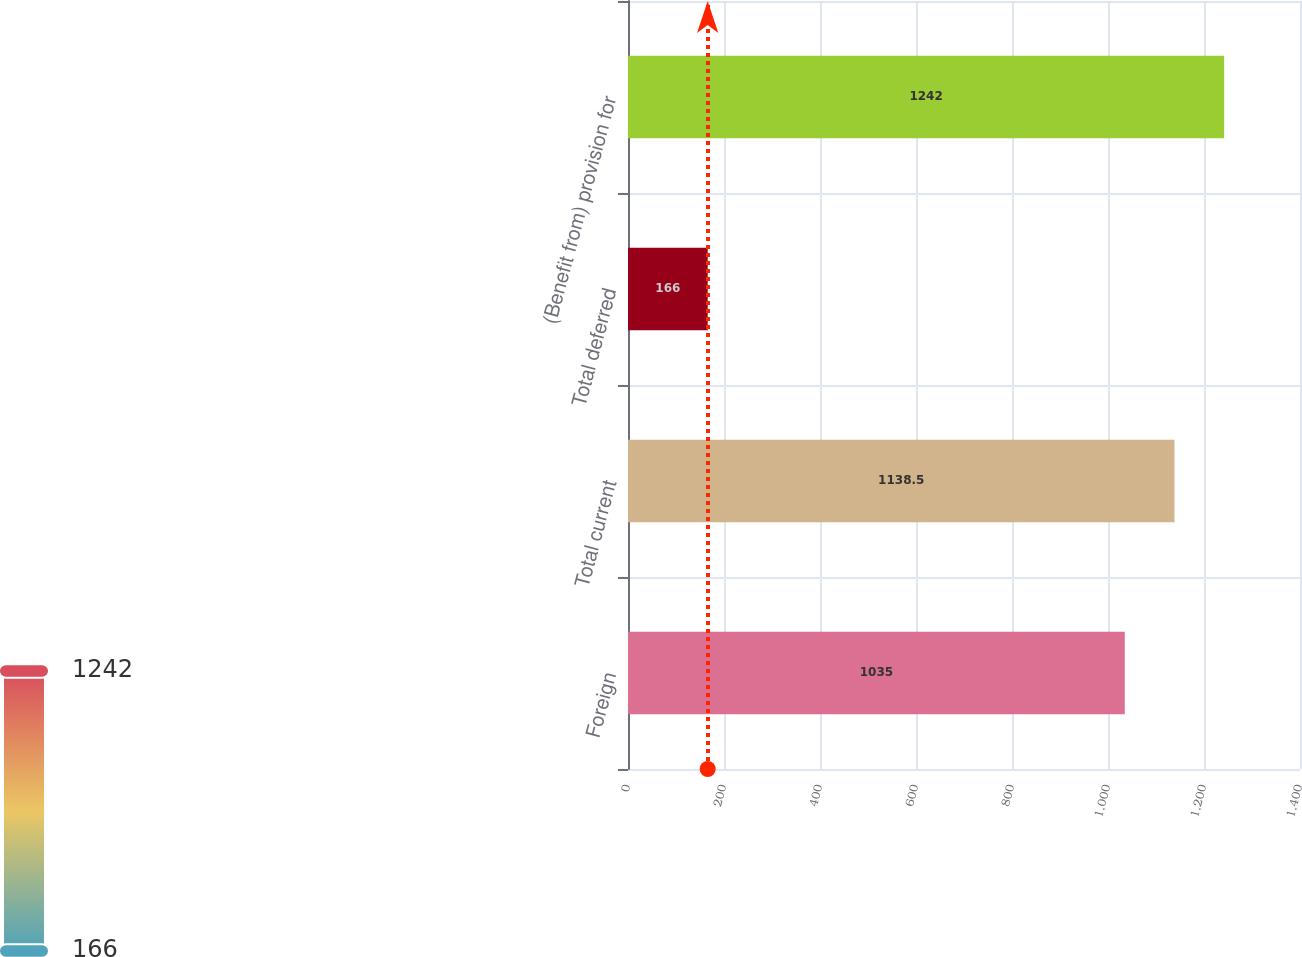Convert chart to OTSL. <chart><loc_0><loc_0><loc_500><loc_500><bar_chart><fcel>Foreign<fcel>Total current<fcel>Total deferred<fcel>(Benefit from) provision for<nl><fcel>1035<fcel>1138.5<fcel>166<fcel>1242<nl></chart> 